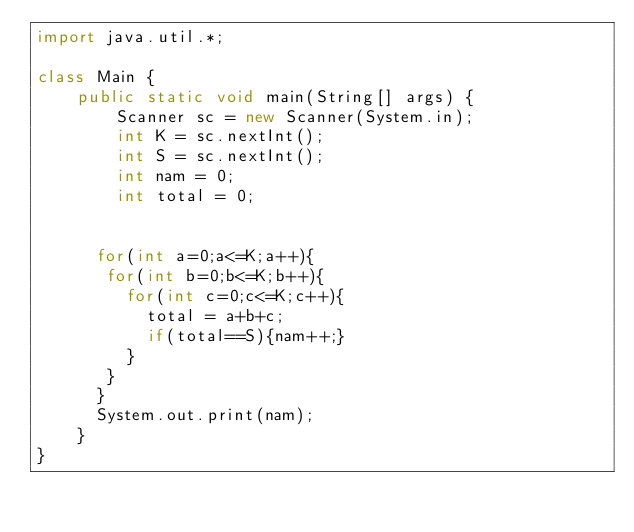Convert code to text. <code><loc_0><loc_0><loc_500><loc_500><_Java_>import java.util.*;
 
class Main {
    public static void main(String[] args) {
        Scanner sc = new Scanner(System.in);
        int K = sc.nextInt();
        int S = sc.nextInt();
        int nam = 0;
        int total = 0;

      
      for(int a=0;a<=K;a++){
       for(int b=0;b<=K;b++){
         for(int c=0;c<=K;c++){
           total = a+b+c;
           if(total==S){nam++;}
         }
       }
      }
      System.out.print(nam);
    }
}</code> 